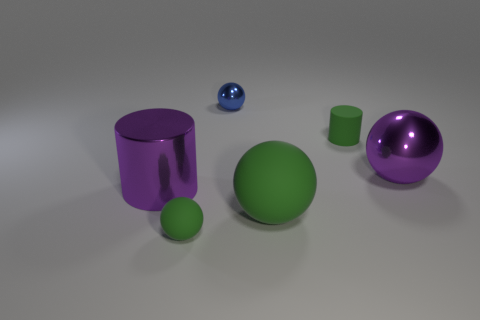The matte object that is the same size as the purple shiny sphere is what shape?
Your response must be concise. Sphere. How many other objects are there of the same material as the blue ball?
Your answer should be compact. 2. Is the color of the large cylinder the same as the large matte thing?
Offer a terse response. No. Is there any other thing that has the same color as the small metal sphere?
Keep it short and to the point. No. There is a small green sphere; are there any small matte balls in front of it?
Your answer should be very brief. No. How big is the metallic thing that is to the left of the small ball that is in front of the tiny blue metal object?
Give a very brief answer. Large. Are there an equal number of green rubber objects that are behind the tiny green matte cylinder and big green balls that are in front of the blue thing?
Provide a succinct answer. No. There is a matte object behind the purple ball; are there any tiny cylinders to the left of it?
Your response must be concise. No. How many purple shiny things are left of the large sphere in front of the purple thing that is on the left side of the small shiny sphere?
Your response must be concise. 1. Is the number of large matte things less than the number of large purple objects?
Offer a very short reply. Yes. 